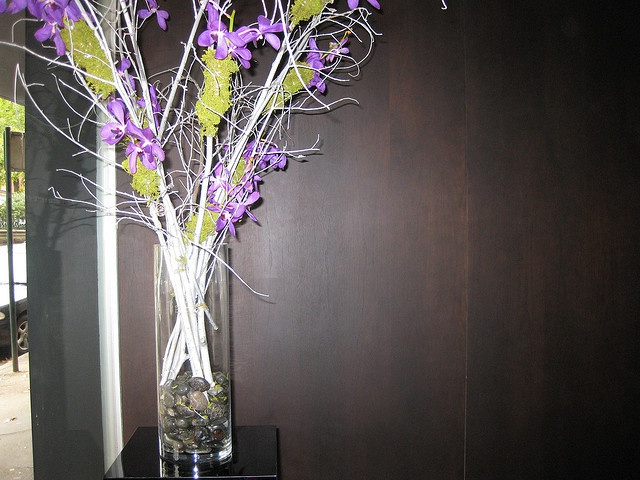Describe the objects in this image and their specific colors. I can see vase in magenta, white, gray, darkgray, and black tones and car in magenta, white, black, gray, and darkgray tones in this image. 